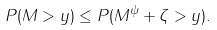<formula> <loc_0><loc_0><loc_500><loc_500>P ( M > y ) \leq P ( M ^ { \psi } + \zeta > y ) .</formula> 